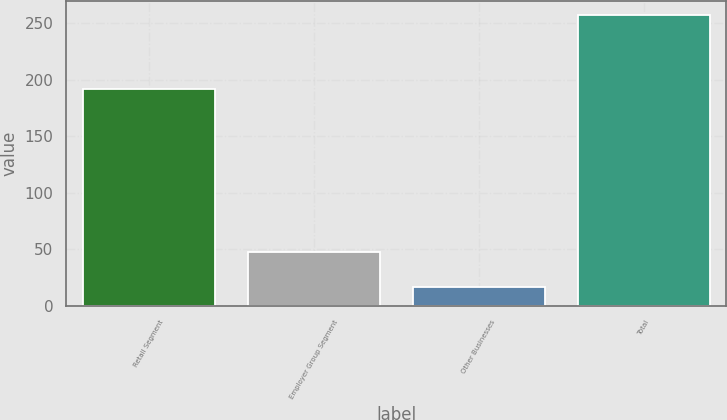Convert chart to OTSL. <chart><loc_0><loc_0><loc_500><loc_500><bar_chart><fcel>Retail Segment<fcel>Employer Group Segment<fcel>Other Businesses<fcel>Total<nl><fcel>192<fcel>48<fcel>17<fcel>257<nl></chart> 